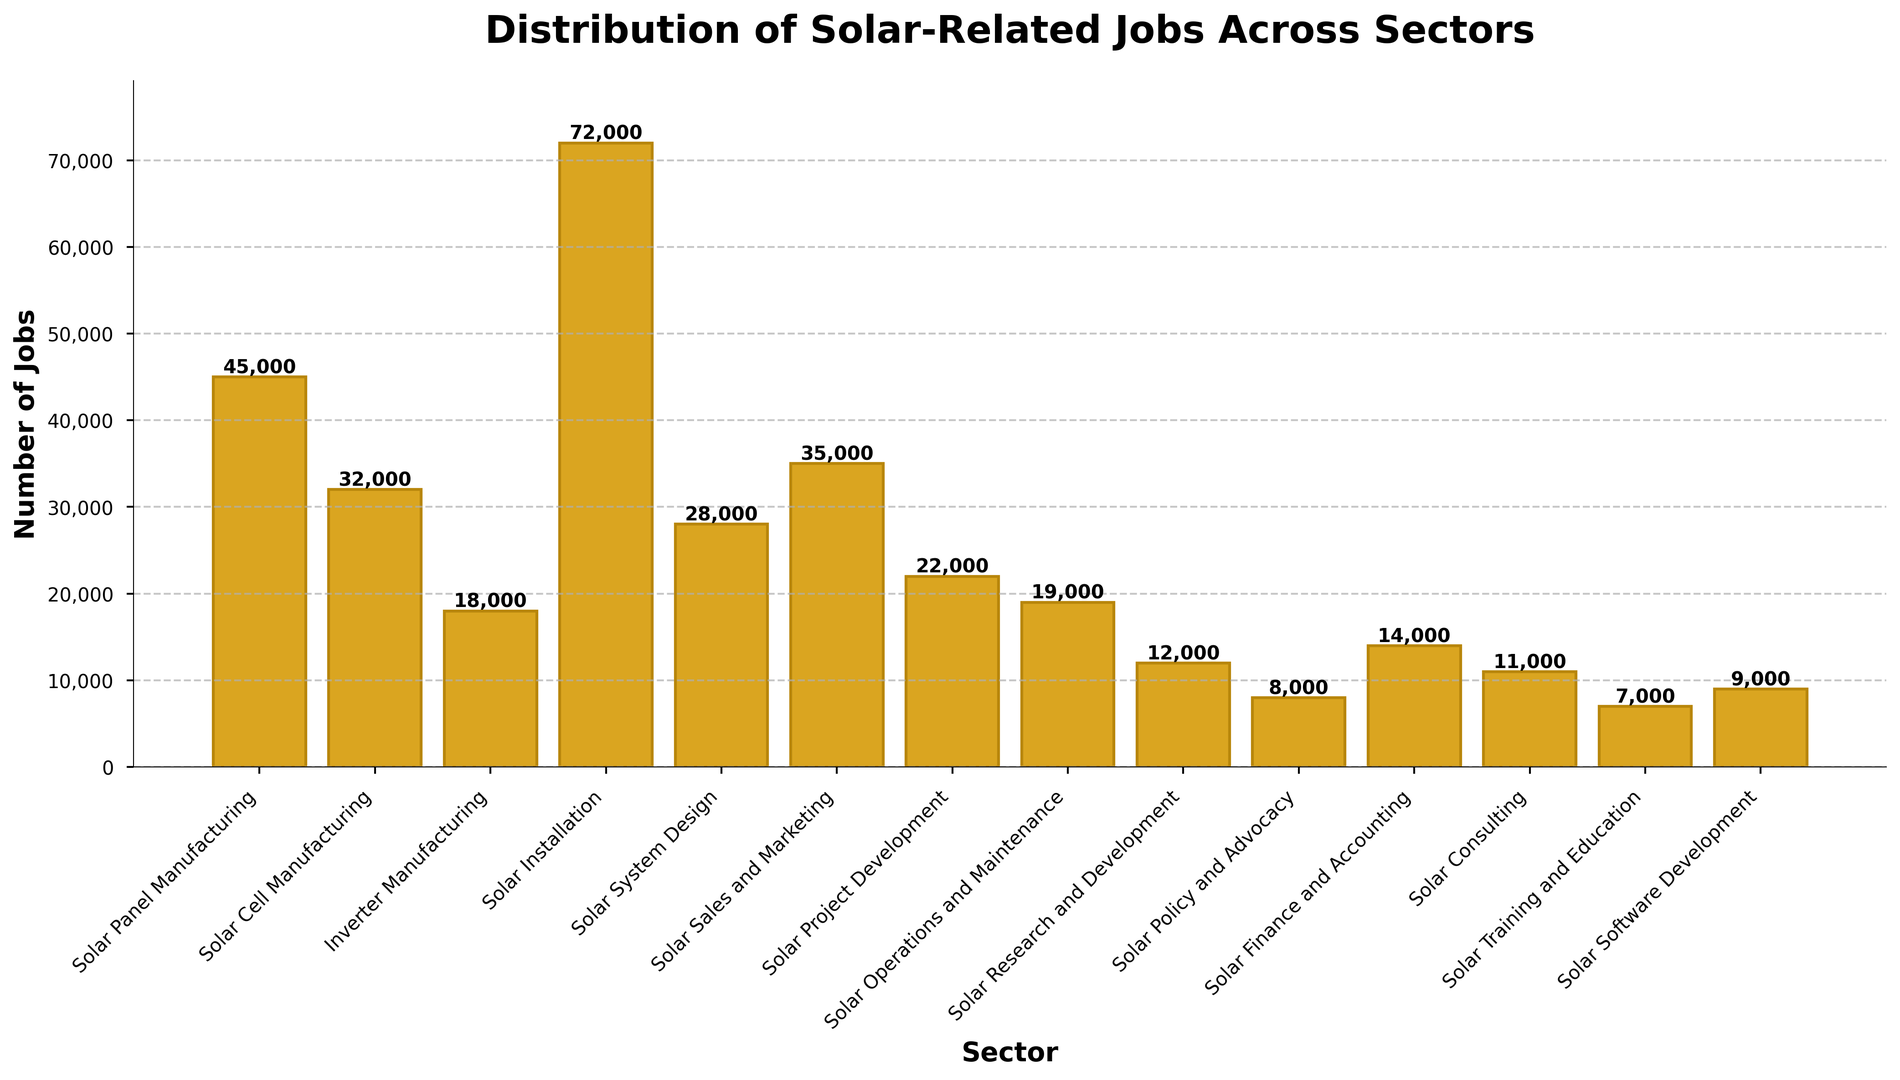What sector has the highest number of jobs? By observing the heights of the bars, the Solar Installation sector has the tallest bar, indicating it has the highest number of jobs.
Answer: Solar Installation What is the total number of jobs in the three manufacturing sectors? Adding the number of jobs from the Solar Panel Manufacturing, Solar Cell Manufacturing, and Inverter Manufacturing sectors: 45,000 + 32,000 + 18,000 = 95,000
Answer: 95,000 How does the number of jobs in Solar System Design compare to Solar Sales and Marketing? Comparing the heights of the bars for these sectors, Solar Sales and Marketing has a taller bar than Solar System Design.
Answer: Solar Sales and Marketing has more jobs Which sector has the fewest jobs? By looking at the shortest bar in the chart, the sector with the fewest jobs is Solar Training and Education.
Answer: Solar Training and Education What is the combined number of jobs in Solar Operations and Maintenance, and Solar Finance and Accounting? Adding the number of jobs in these two sectors: 19,000 + 14,000 = 33,000
Answer: 33,000 Which sector has more jobs, Solar Policy and Advocacy or Solar Consulting? By comparing the bars for these two sectors, Solar Consulting has a taller bar, indicating more jobs than Solar Policy and Advocacy.
Answer: Solar Consulting What is the average number of jobs across all sectors? Summing up the total number of jobs and dividing by the number of sectors: (45,000 + 32,000 + 18,000 + 72,000 + 28,000 + 35,000 + 22,000 + 19,000 + 12,000 + 8,000 + 14,000 + 11,000 + 7,000 + 9,000) = 332,000; 332,000 / 14 ≈ 23,714
Answer: 23,714 How does the number of jobs in Solar Installation compare to the combined number of Solar Sales and Marketing, Solar Project Development, and Solar Operations and Maintenance? Adding the jobs in Solar Sales and Marketing, Solar Project Development, and Solar Operations and Maintenance: 35,000 + 22,000 + 19,000 = 76,000. Solar Installation has 72,000, which is less than 76,000.
Answer: Combined sectors have more jobs What's the difference in the number of jobs between the sector with the most jobs and the sector with the fewest jobs? Subtracting the number of jobs in the sector with the fewest jobs (Solar Training and Education) from the sector with the most jobs (Solar Installation): 72,000 - 7,000 = 65,000
Answer: 65,000 